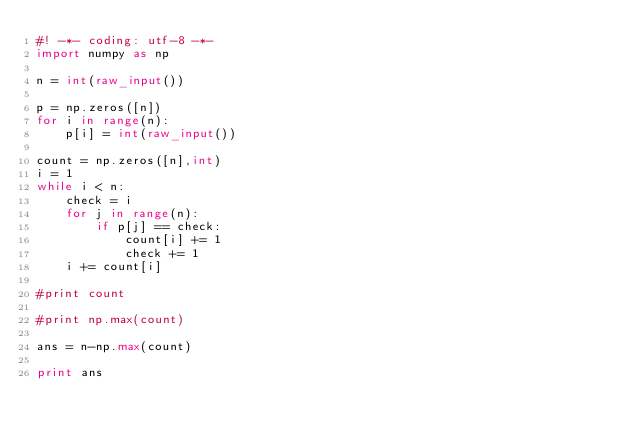<code> <loc_0><loc_0><loc_500><loc_500><_Python_>#! -*- coding: utf-8 -*-
import numpy as np

n = int(raw_input())

p = np.zeros([n])
for i in range(n):
    p[i] = int(raw_input())

count = np.zeros([n],int)
i = 1
while i < n:
    check = i
    for j in range(n):
        if p[j] == check:
            count[i] += 1
            check += 1
    i += count[i]

#print count

#print np.max(count)

ans = n-np.max(count)

print ans
</code> 